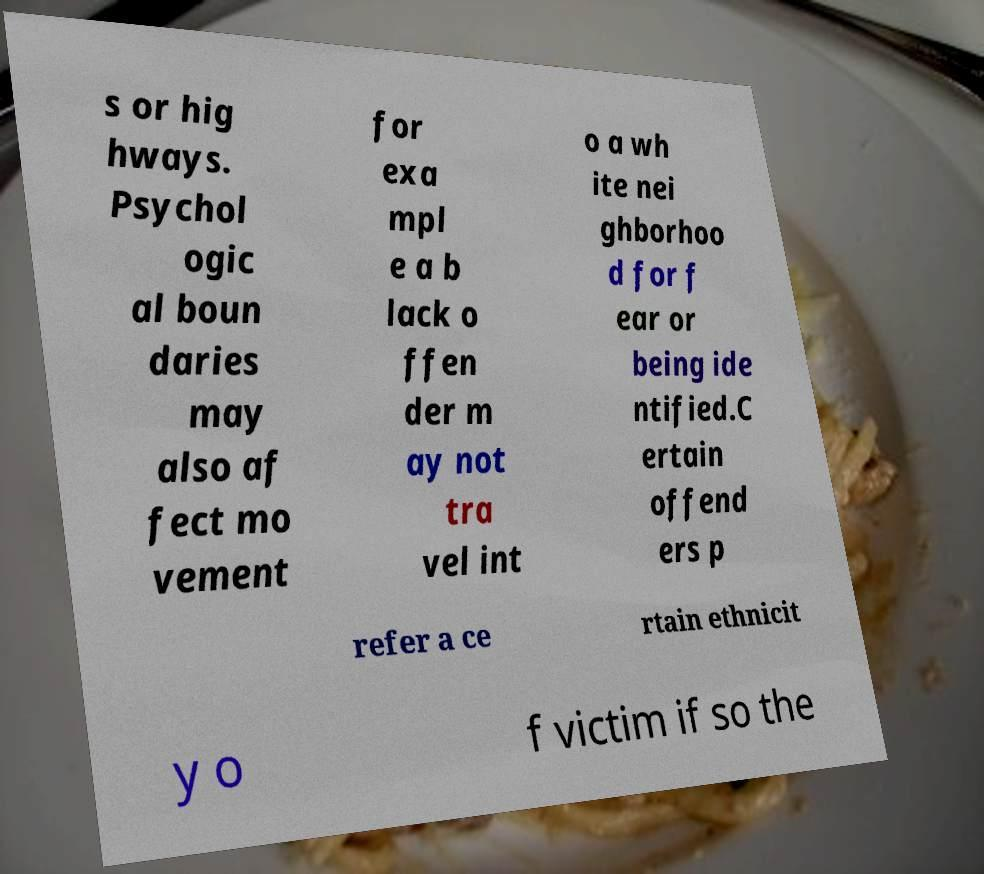For documentation purposes, I need the text within this image transcribed. Could you provide that? s or hig hways. Psychol ogic al boun daries may also af fect mo vement for exa mpl e a b lack o ffen der m ay not tra vel int o a wh ite nei ghborhoo d for f ear or being ide ntified.C ertain offend ers p refer a ce rtain ethnicit y o f victim if so the 